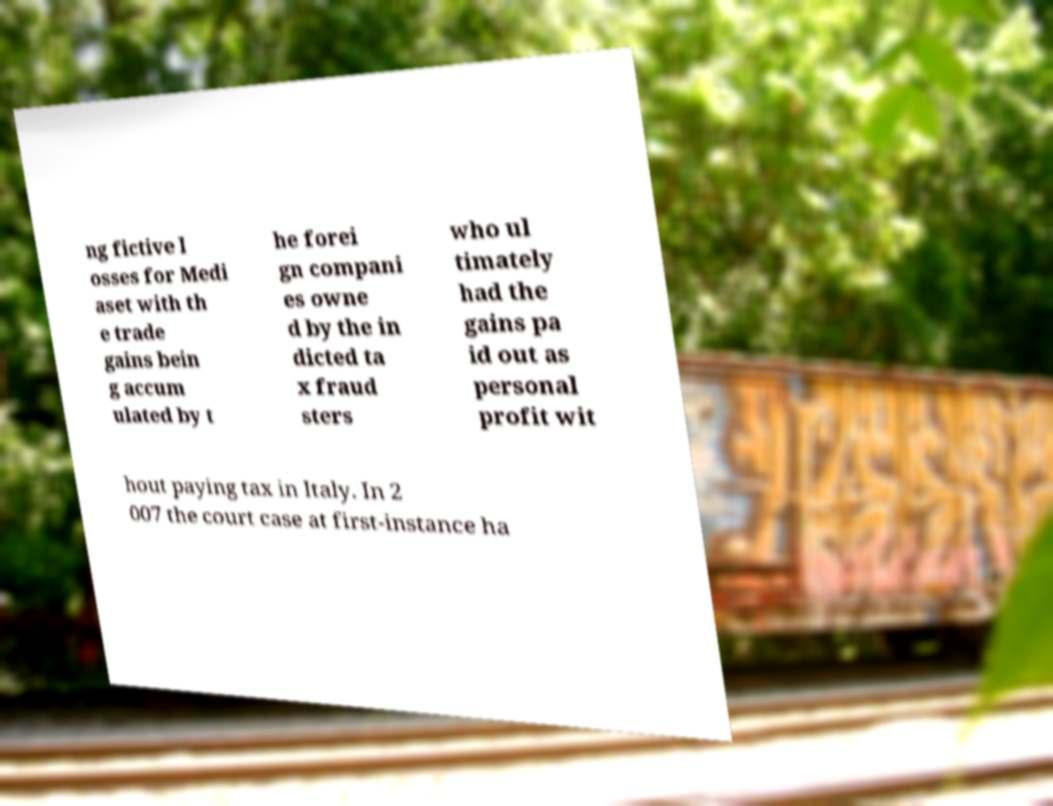Can you read and provide the text displayed in the image?This photo seems to have some interesting text. Can you extract and type it out for me? ng fictive l osses for Medi aset with th e trade gains bein g accum ulated by t he forei gn compani es owne d by the in dicted ta x fraud sters who ul timately had the gains pa id out as personal profit wit hout paying tax in Italy. In 2 007 the court case at first-instance ha 